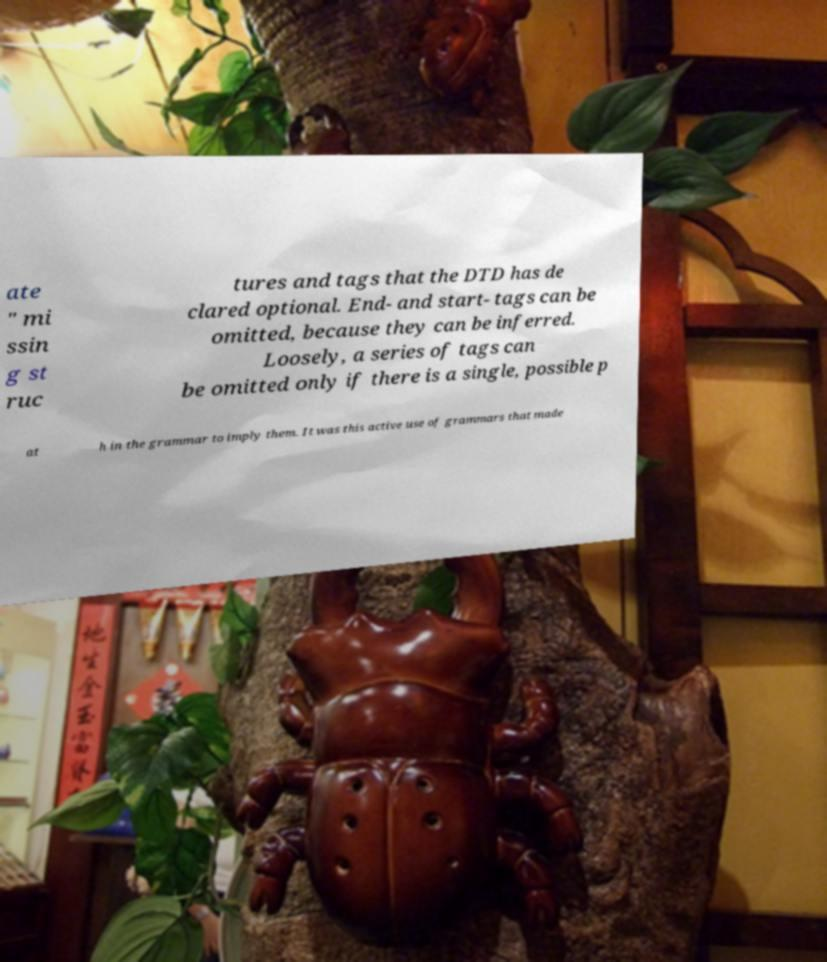Could you extract and type out the text from this image? ate " mi ssin g st ruc tures and tags that the DTD has de clared optional. End- and start- tags can be omitted, because they can be inferred. Loosely, a series of tags can be omitted only if there is a single, possible p at h in the grammar to imply them. It was this active use of grammars that made 